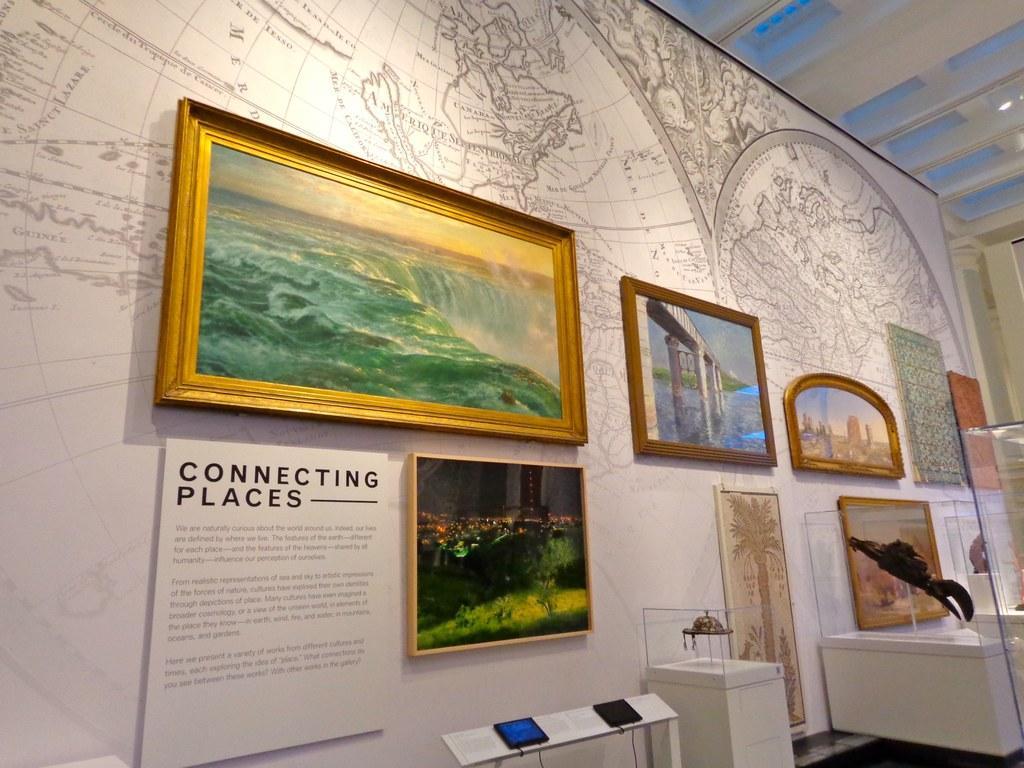Please provide a concise description of this image. In this image there is a wall on which there are photo frames. In front of them there are some vintage monuments kept in the glass boxes. On the wall there is a design of the map. At the top there is ceiling. 